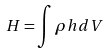<formula> <loc_0><loc_0><loc_500><loc_500>H = \int \rho h d V</formula> 